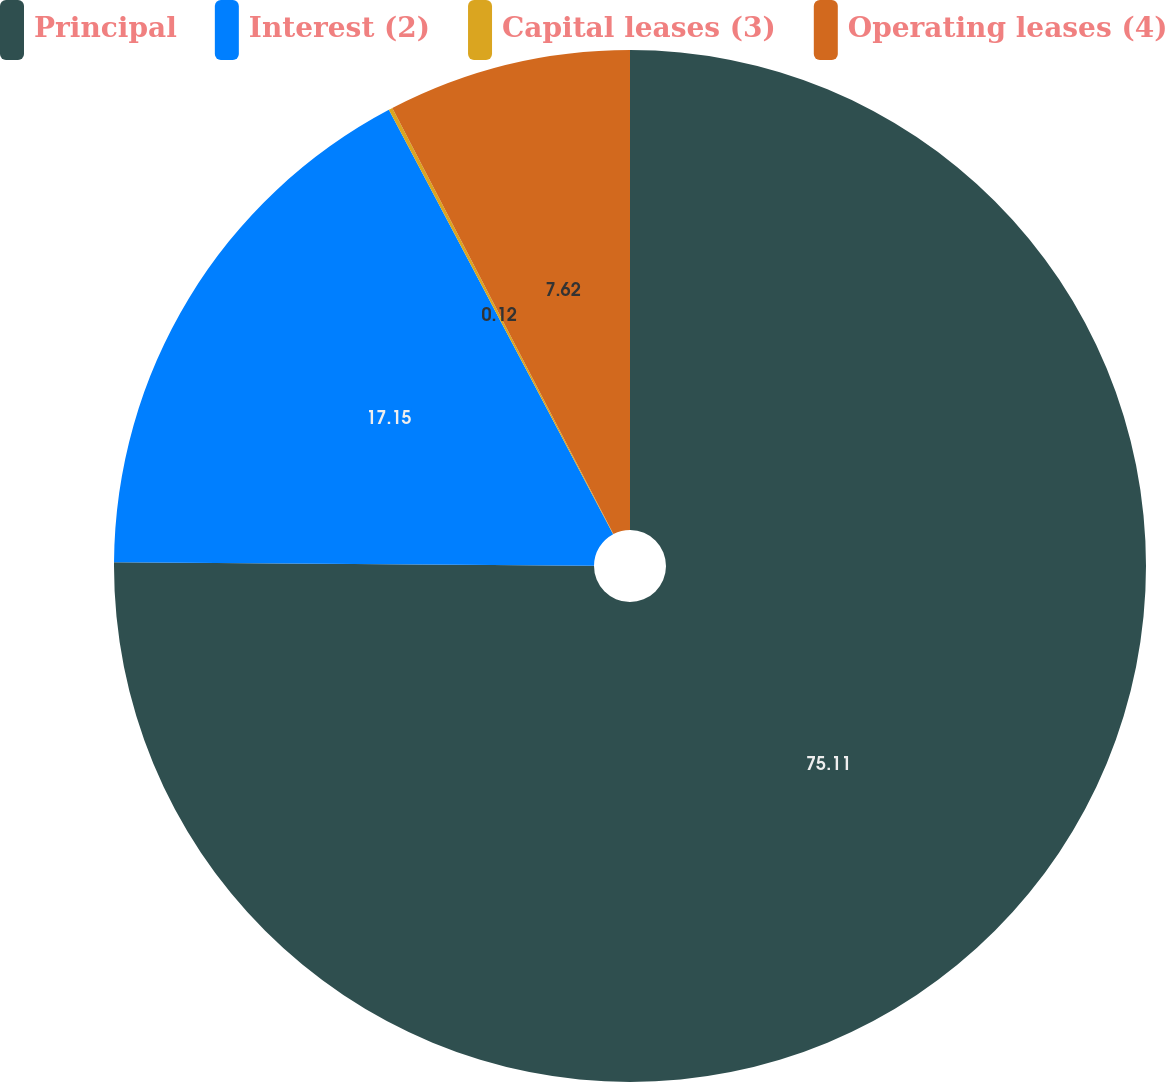Convert chart. <chart><loc_0><loc_0><loc_500><loc_500><pie_chart><fcel>Principal<fcel>Interest (2)<fcel>Capital leases (3)<fcel>Operating leases (4)<nl><fcel>75.12%<fcel>17.15%<fcel>0.12%<fcel>7.62%<nl></chart> 